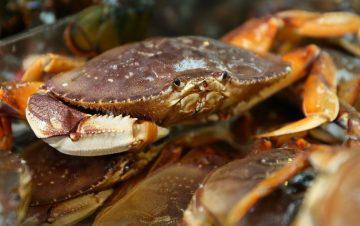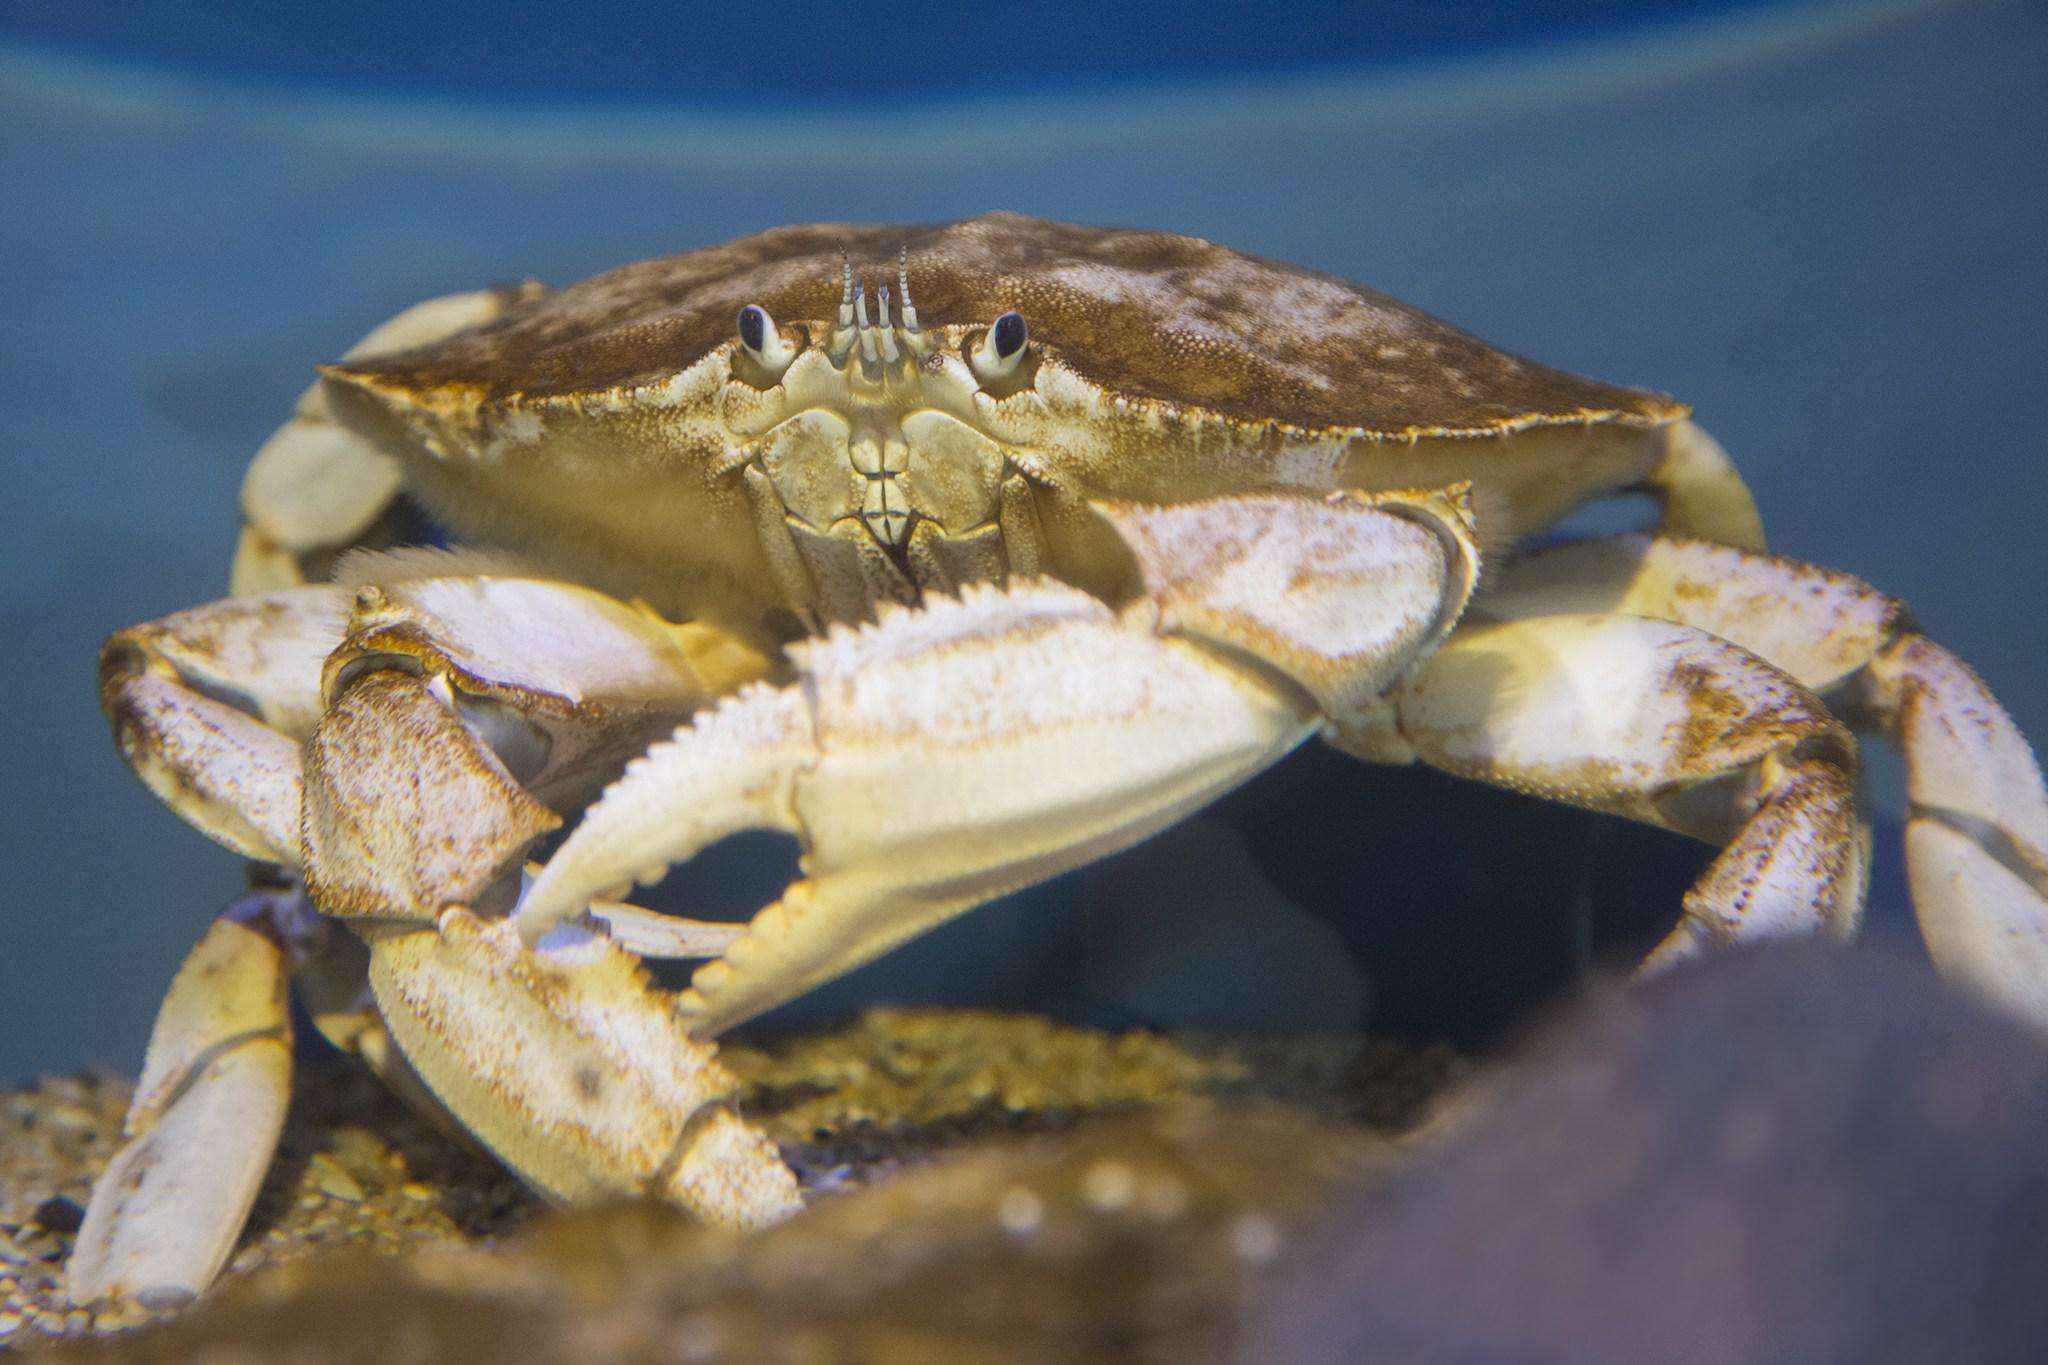The first image is the image on the left, the second image is the image on the right. Examine the images to the left and right. Is the description "Each image contains exactly one prominent forward-facing crab, and no image contains a part of a human." accurate? Answer yes or no. Yes. 